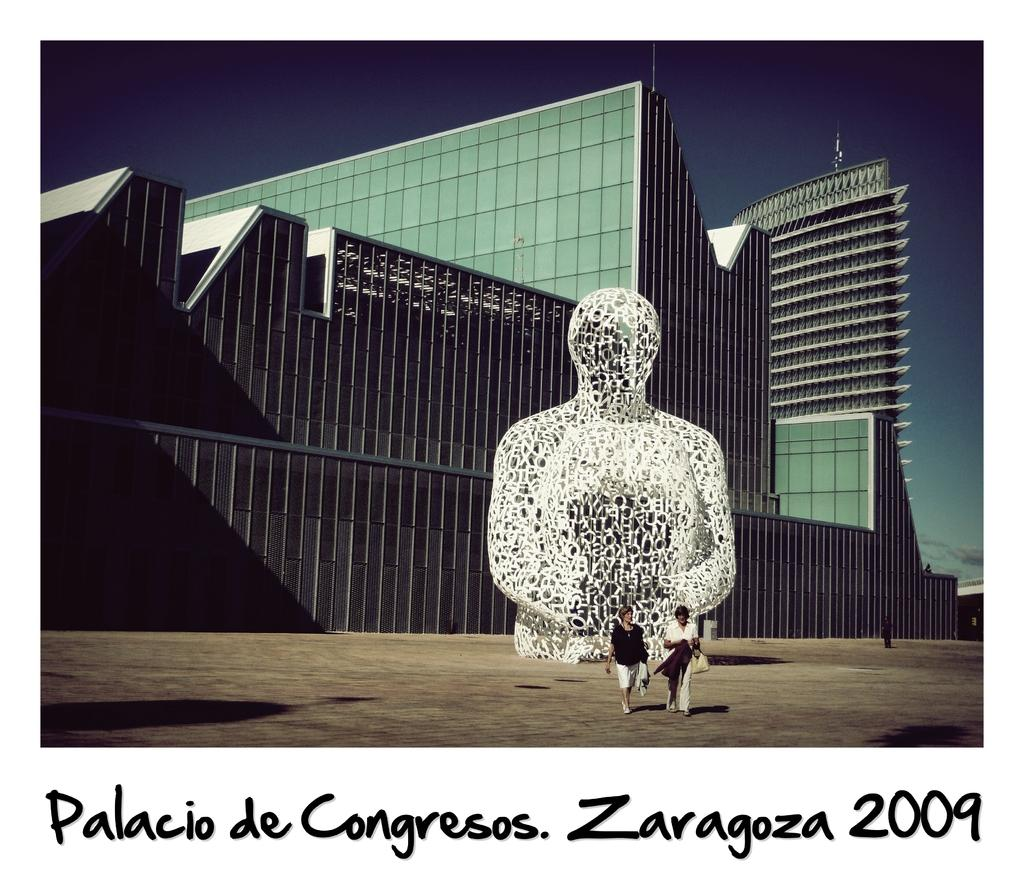<image>
Describe the image concisely. A photo from Zaragoza in 2009 shows a sculpture. 